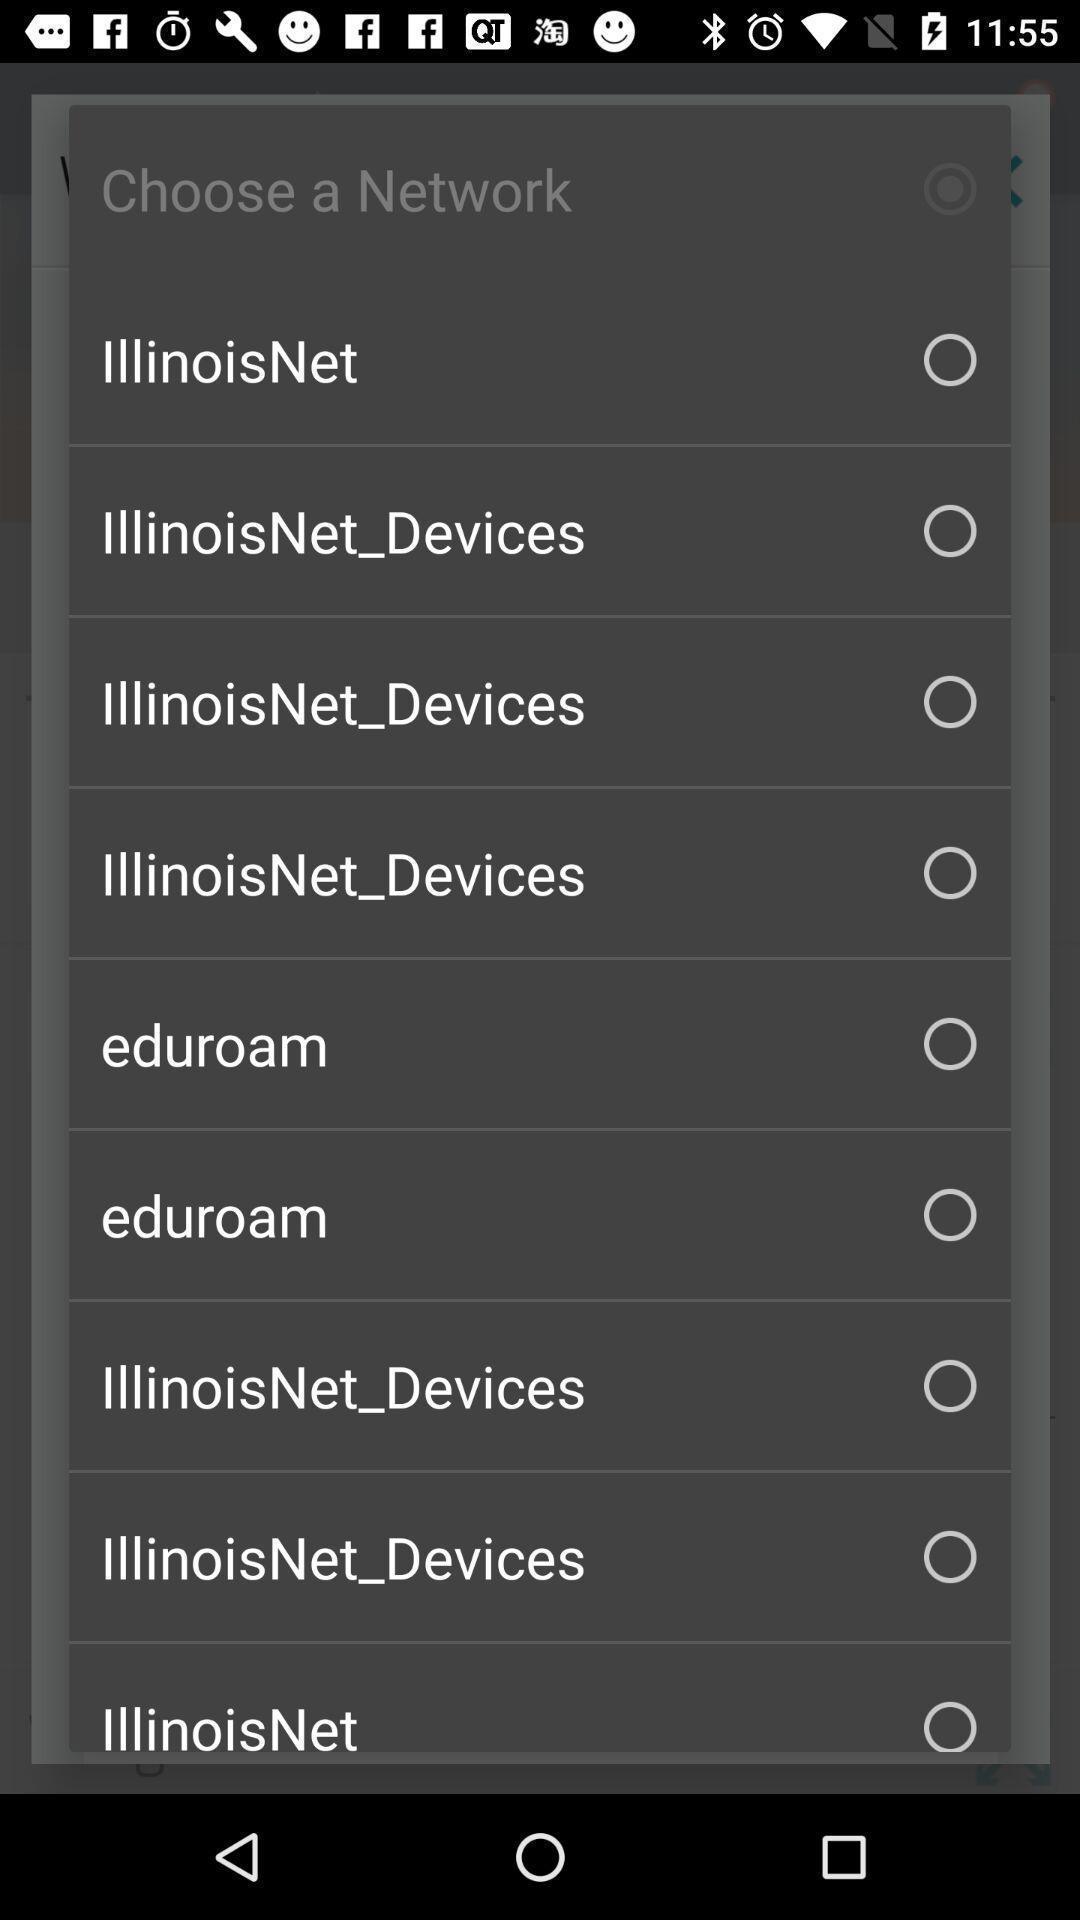Provide a description of this screenshot. Screen showing the list of options to choose network. 